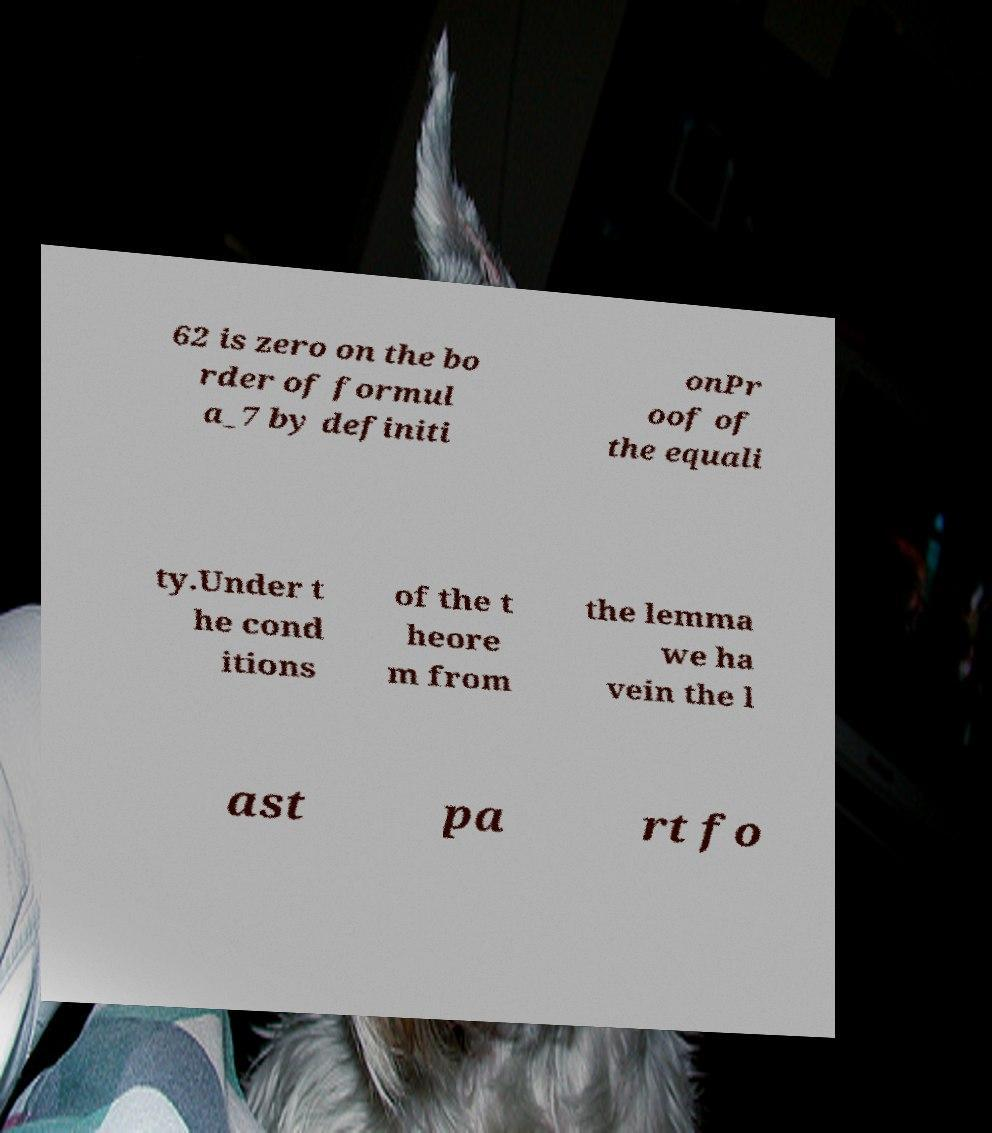What messages or text are displayed in this image? I need them in a readable, typed format. 62 is zero on the bo rder of formul a_7 by definiti onPr oof of the equali ty.Under t he cond itions of the t heore m from the lemma we ha vein the l ast pa rt fo 